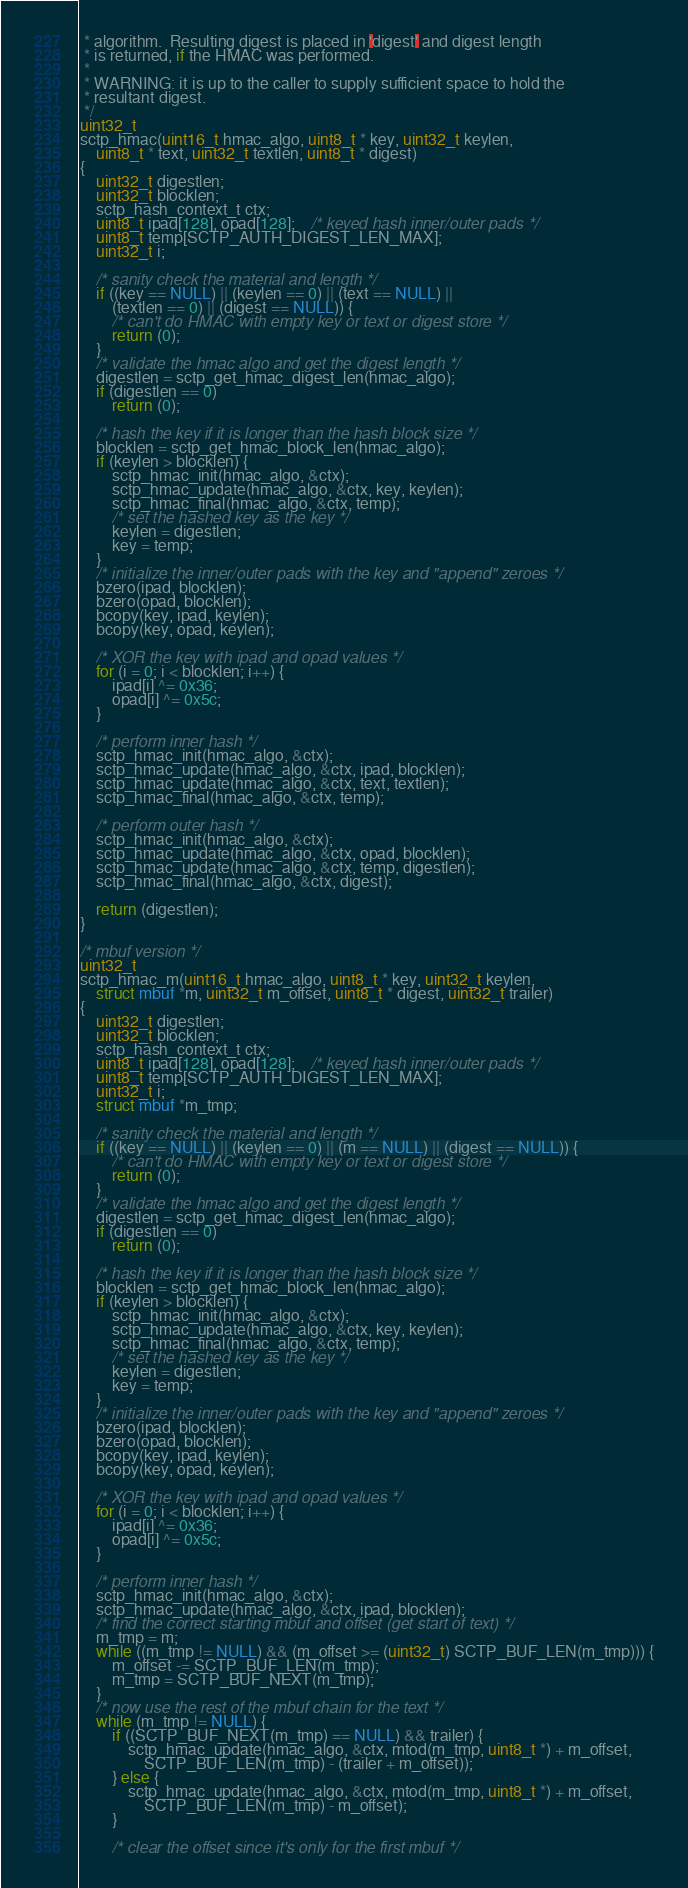<code> <loc_0><loc_0><loc_500><loc_500><_C_> * algorithm.  Resulting digest is placed in 'digest' and digest length
 * is returned, if the HMAC was performed.
 *
 * WARNING: it is up to the caller to supply sufficient space to hold the
 * resultant digest.
 */
uint32_t
sctp_hmac(uint16_t hmac_algo, uint8_t * key, uint32_t keylen,
    uint8_t * text, uint32_t textlen, uint8_t * digest)
{
	uint32_t digestlen;
	uint32_t blocklen;
	sctp_hash_context_t ctx;
	uint8_t ipad[128], opad[128];	/* keyed hash inner/outer pads */
	uint8_t temp[SCTP_AUTH_DIGEST_LEN_MAX];
	uint32_t i;

	/* sanity check the material and length */
	if ((key == NULL) || (keylen == 0) || (text == NULL) ||
	    (textlen == 0) || (digest == NULL)) {
		/* can't do HMAC with empty key or text or digest store */
		return (0);
	}
	/* validate the hmac algo and get the digest length */
	digestlen = sctp_get_hmac_digest_len(hmac_algo);
	if (digestlen == 0)
		return (0);

	/* hash the key if it is longer than the hash block size */
	blocklen = sctp_get_hmac_block_len(hmac_algo);
	if (keylen > blocklen) {
		sctp_hmac_init(hmac_algo, &ctx);
		sctp_hmac_update(hmac_algo, &ctx, key, keylen);
		sctp_hmac_final(hmac_algo, &ctx, temp);
		/* set the hashed key as the key */
		keylen = digestlen;
		key = temp;
	}
	/* initialize the inner/outer pads with the key and "append" zeroes */
	bzero(ipad, blocklen);
	bzero(opad, blocklen);
	bcopy(key, ipad, keylen);
	bcopy(key, opad, keylen);

	/* XOR the key with ipad and opad values */
	for (i = 0; i < blocklen; i++) {
		ipad[i] ^= 0x36;
		opad[i] ^= 0x5c;
	}

	/* perform inner hash */
	sctp_hmac_init(hmac_algo, &ctx);
	sctp_hmac_update(hmac_algo, &ctx, ipad, blocklen);
	sctp_hmac_update(hmac_algo, &ctx, text, textlen);
	sctp_hmac_final(hmac_algo, &ctx, temp);

	/* perform outer hash */
	sctp_hmac_init(hmac_algo, &ctx);
	sctp_hmac_update(hmac_algo, &ctx, opad, blocklen);
	sctp_hmac_update(hmac_algo, &ctx, temp, digestlen);
	sctp_hmac_final(hmac_algo, &ctx, digest);

	return (digestlen);
}

/* mbuf version */
uint32_t
sctp_hmac_m(uint16_t hmac_algo, uint8_t * key, uint32_t keylen,
    struct mbuf *m, uint32_t m_offset, uint8_t * digest, uint32_t trailer)
{
	uint32_t digestlen;
	uint32_t blocklen;
	sctp_hash_context_t ctx;
	uint8_t ipad[128], opad[128];	/* keyed hash inner/outer pads */
	uint8_t temp[SCTP_AUTH_DIGEST_LEN_MAX];
	uint32_t i;
	struct mbuf *m_tmp;

	/* sanity check the material and length */
	if ((key == NULL) || (keylen == 0) || (m == NULL) || (digest == NULL)) {
		/* can't do HMAC with empty key or text or digest store */
		return (0);
	}
	/* validate the hmac algo and get the digest length */
	digestlen = sctp_get_hmac_digest_len(hmac_algo);
	if (digestlen == 0)
		return (0);

	/* hash the key if it is longer than the hash block size */
	blocklen = sctp_get_hmac_block_len(hmac_algo);
	if (keylen > blocklen) {
		sctp_hmac_init(hmac_algo, &ctx);
		sctp_hmac_update(hmac_algo, &ctx, key, keylen);
		sctp_hmac_final(hmac_algo, &ctx, temp);
		/* set the hashed key as the key */
		keylen = digestlen;
		key = temp;
	}
	/* initialize the inner/outer pads with the key and "append" zeroes */
	bzero(ipad, blocklen);
	bzero(opad, blocklen);
	bcopy(key, ipad, keylen);
	bcopy(key, opad, keylen);

	/* XOR the key with ipad and opad values */
	for (i = 0; i < blocklen; i++) {
		ipad[i] ^= 0x36;
		opad[i] ^= 0x5c;
	}

	/* perform inner hash */
	sctp_hmac_init(hmac_algo, &ctx);
	sctp_hmac_update(hmac_algo, &ctx, ipad, blocklen);
	/* find the correct starting mbuf and offset (get start of text) */
	m_tmp = m;
	while ((m_tmp != NULL) && (m_offset >= (uint32_t) SCTP_BUF_LEN(m_tmp))) {
		m_offset -= SCTP_BUF_LEN(m_tmp);
		m_tmp = SCTP_BUF_NEXT(m_tmp);
	}
	/* now use the rest of the mbuf chain for the text */
	while (m_tmp != NULL) {
		if ((SCTP_BUF_NEXT(m_tmp) == NULL) && trailer) {
			sctp_hmac_update(hmac_algo, &ctx, mtod(m_tmp, uint8_t *) + m_offset,
			    SCTP_BUF_LEN(m_tmp) - (trailer + m_offset));
		} else {
			sctp_hmac_update(hmac_algo, &ctx, mtod(m_tmp, uint8_t *) + m_offset,
			    SCTP_BUF_LEN(m_tmp) - m_offset);
		}

		/* clear the offset since it's only for the first mbuf */</code> 